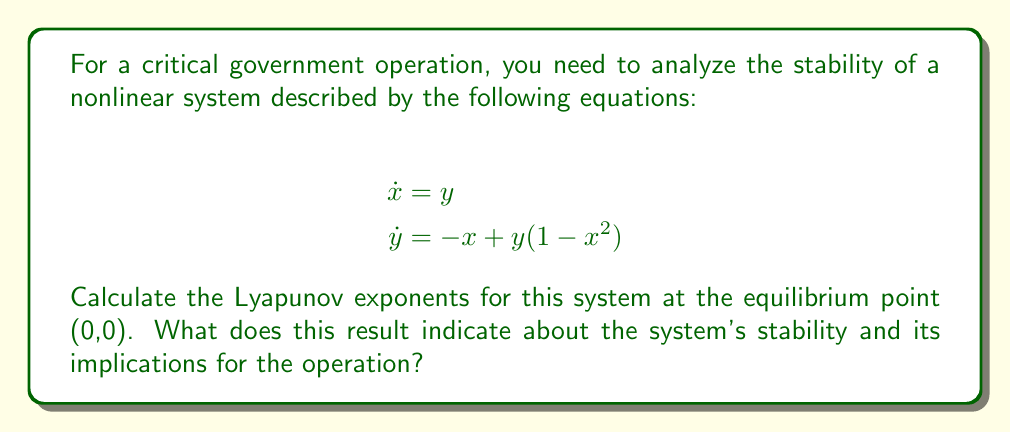Could you help me with this problem? To analyze the stability of this nonlinear system using Lyapunov exponents, we'll follow these steps:

1. Linearize the system around the equilibrium point (0,0):
   The Jacobian matrix at (0,0) is:
   $$J = \begin{bmatrix}
   \frac{\partial \dot{x}}{\partial x} & \frac{\partial \dot{x}}{\partial y} \\
   \frac{\partial \dot{y}}{\partial x} & \frac{\partial \dot{y}}{\partial y}
   \end{bmatrix} = \begin{bmatrix}
   0 & 1 \\
   -1 & 1
   \end{bmatrix}$$

2. Find the eigenvalues of the Jacobian matrix:
   $$\det(J - \lambda I) = \begin{vmatrix}
   -\lambda & 1 \\
   -1 & 1-\lambda
   \end{vmatrix} = \lambda^2 - \lambda + 1 = 0$$
   
   Solving this characteristic equation:
   $$\lambda = \frac{1 \pm \sqrt{1-4}}{2} = \frac{1 \pm i\sqrt{3}}{2}$$

3. The Lyapunov exponents are the real parts of these eigenvalues:
   $$\lambda_1 = \lambda_2 = \frac{1}{2}$$

4. Interpret the results:
   - Positive Lyapunov exponents indicate exponential divergence of nearby trajectories, suggesting chaos.
   - Zero Lyapunov exponents indicate conservation of distance between trajectories.
   - Negative Lyapunov exponents indicate convergence of trajectories, suggesting stability.

In this case, both Lyapunov exponents are positive (1/2), indicating that the system is unstable and potentially chaotic at the equilibrium point (0,0).

For the government operation, this implies that small perturbations or uncertainties in the initial conditions can lead to significantly different outcomes over time. This instability could potentially compromise the smooth execution of field operations, requiring careful monitoring and adaptive strategies.
Answer: Lyapunov exponents: $\lambda_1 = \lambda_2 = \frac{1}{2}$. The system is unstable and potentially chaotic at (0,0), implying high sensitivity to initial conditions in operations. 